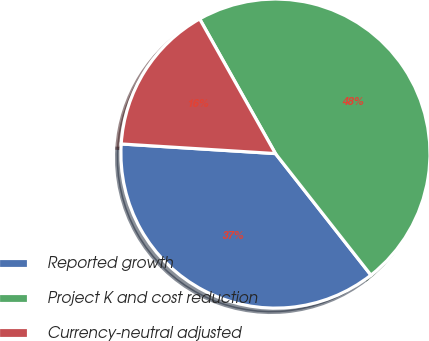Convert chart. <chart><loc_0><loc_0><loc_500><loc_500><pie_chart><fcel>Reported growth<fcel>Project K and cost reduction<fcel>Currency-neutral adjusted<nl><fcel>36.59%<fcel>47.56%<fcel>15.85%<nl></chart> 